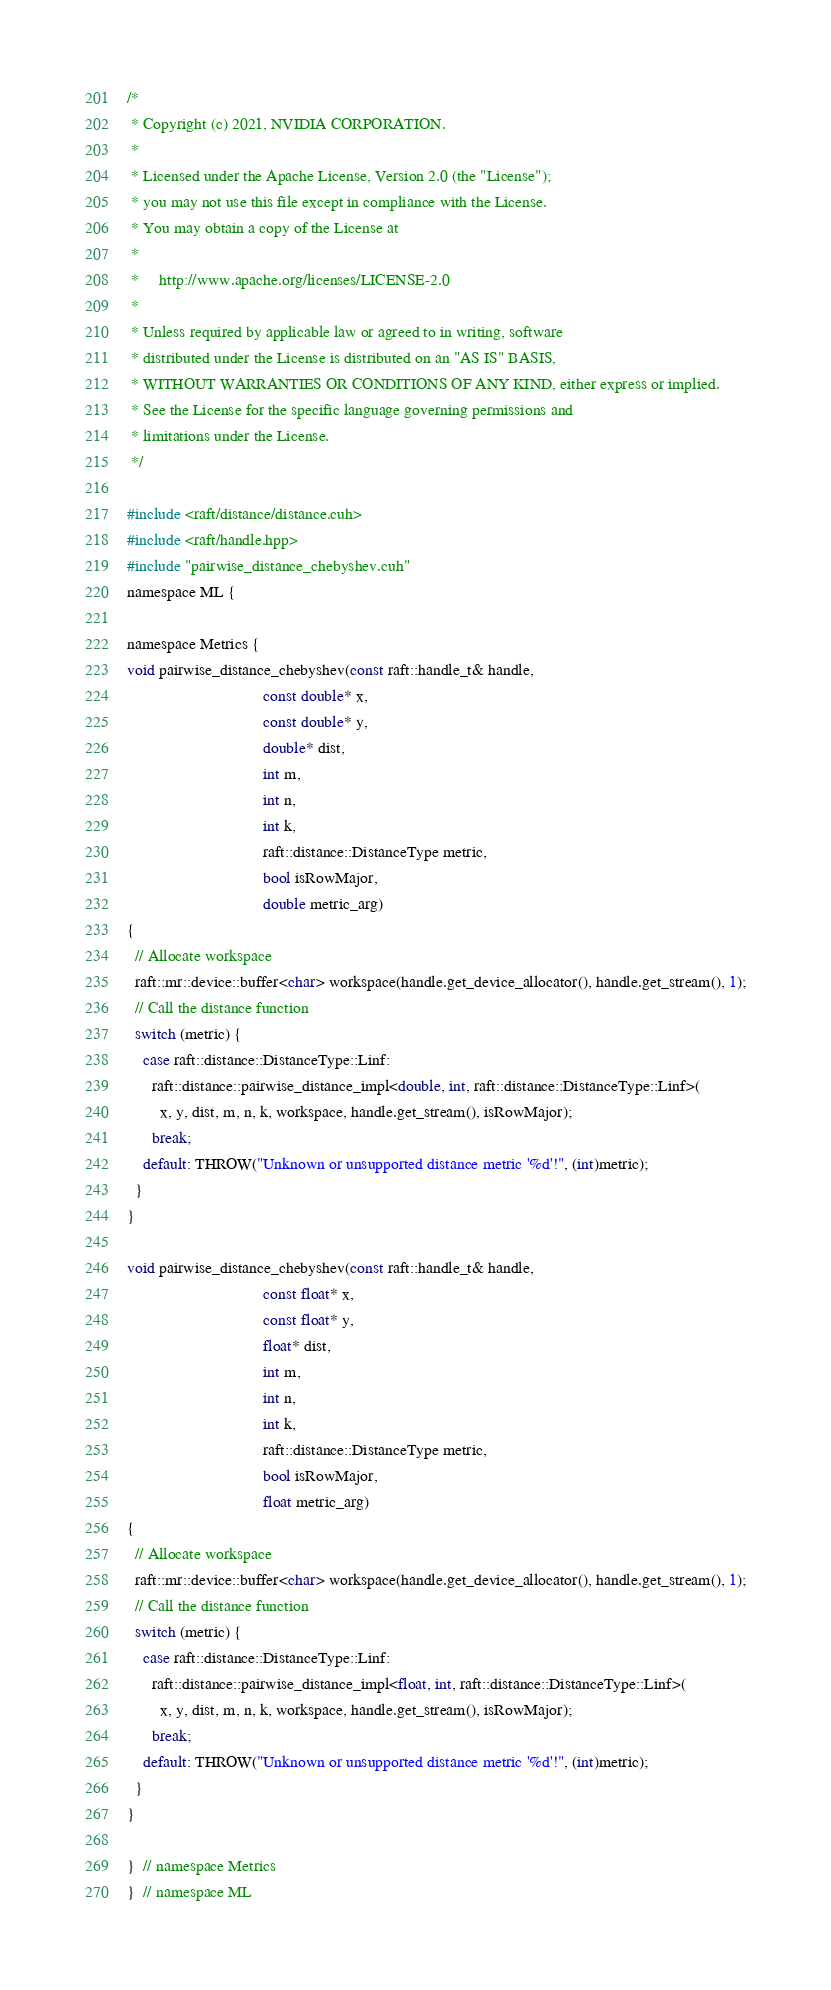<code> <loc_0><loc_0><loc_500><loc_500><_Cuda_>
/*
 * Copyright (c) 2021, NVIDIA CORPORATION.
 *
 * Licensed under the Apache License, Version 2.0 (the "License");
 * you may not use this file except in compliance with the License.
 * You may obtain a copy of the License at
 *
 *     http://www.apache.org/licenses/LICENSE-2.0
 *
 * Unless required by applicable law or agreed to in writing, software
 * distributed under the License is distributed on an "AS IS" BASIS,
 * WITHOUT WARRANTIES OR CONDITIONS OF ANY KIND, either express or implied.
 * See the License for the specific language governing permissions and
 * limitations under the License.
 */

#include <raft/distance/distance.cuh>
#include <raft/handle.hpp>
#include "pairwise_distance_chebyshev.cuh"
namespace ML {

namespace Metrics {
void pairwise_distance_chebyshev(const raft::handle_t& handle,
                                 const double* x,
                                 const double* y,
                                 double* dist,
                                 int m,
                                 int n,
                                 int k,
                                 raft::distance::DistanceType metric,
                                 bool isRowMajor,
                                 double metric_arg)
{
  // Allocate workspace
  raft::mr::device::buffer<char> workspace(handle.get_device_allocator(), handle.get_stream(), 1);
  // Call the distance function
  switch (metric) {
    case raft::distance::DistanceType::Linf:
      raft::distance::pairwise_distance_impl<double, int, raft::distance::DistanceType::Linf>(
        x, y, dist, m, n, k, workspace, handle.get_stream(), isRowMajor);
      break;
    default: THROW("Unknown or unsupported distance metric '%d'!", (int)metric);
  }
}

void pairwise_distance_chebyshev(const raft::handle_t& handle,
                                 const float* x,
                                 const float* y,
                                 float* dist,
                                 int m,
                                 int n,
                                 int k,
                                 raft::distance::DistanceType metric,
                                 bool isRowMajor,
                                 float metric_arg)
{
  // Allocate workspace
  raft::mr::device::buffer<char> workspace(handle.get_device_allocator(), handle.get_stream(), 1);
  // Call the distance function
  switch (metric) {
    case raft::distance::DistanceType::Linf:
      raft::distance::pairwise_distance_impl<float, int, raft::distance::DistanceType::Linf>(
        x, y, dist, m, n, k, workspace, handle.get_stream(), isRowMajor);
      break;
    default: THROW("Unknown or unsupported distance metric '%d'!", (int)metric);
  }
}

}  // namespace Metrics
}  // namespace ML
</code> 